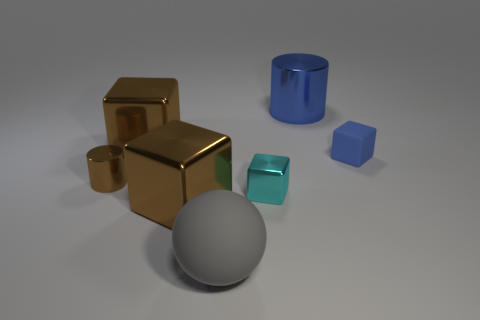Do the large cube that is in front of the small cyan shiny block and the brown cylinder have the same material?
Your response must be concise. Yes. What is the size of the metallic cylinder left of the big cube that is behind the rubber thing to the right of the large blue shiny cylinder?
Your answer should be compact. Small. What number of other objects are there of the same color as the large shiny cylinder?
Keep it short and to the point. 1. There is a gray matte thing that is the same size as the blue cylinder; what shape is it?
Your answer should be compact. Sphere. There is a brown block that is in front of the blue rubber thing; what is its size?
Your answer should be very brief. Large. There is a metallic cylinder that is in front of the large cylinder; is it the same color as the big block in front of the tiny metallic cylinder?
Offer a very short reply. Yes. There is a tiny object that is to the left of the sphere that is in front of the metallic cube that is to the right of the gray object; what is it made of?
Keep it short and to the point. Metal. Are there any brown objects that have the same size as the blue metal cylinder?
Your answer should be compact. Yes. What material is the brown object that is the same size as the cyan metal thing?
Offer a very short reply. Metal. What is the shape of the rubber object behind the small brown metallic cylinder?
Your answer should be compact. Cube. 